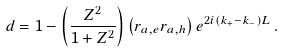<formula> <loc_0><loc_0><loc_500><loc_500>d = 1 - \left ( \frac { Z ^ { 2 } } { 1 + Z ^ { 2 } } \right ) \left ( r _ { a , e } r _ { a , h } \right ) e ^ { 2 i ( k _ { + } - k _ { - } ) L } \, .</formula> 